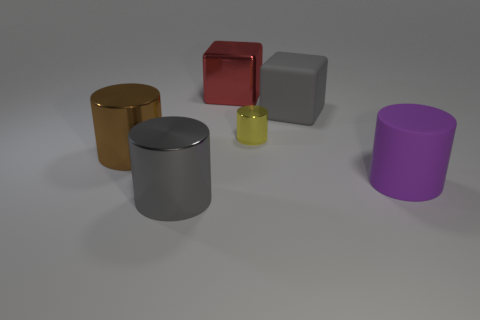There is an object behind the large matte object that is behind the big cylinder right of the shiny block; what is its size? The object in question appears to be of a small size relative to the larger objects in the scene, particularly the large matte object and the big cylinder. 